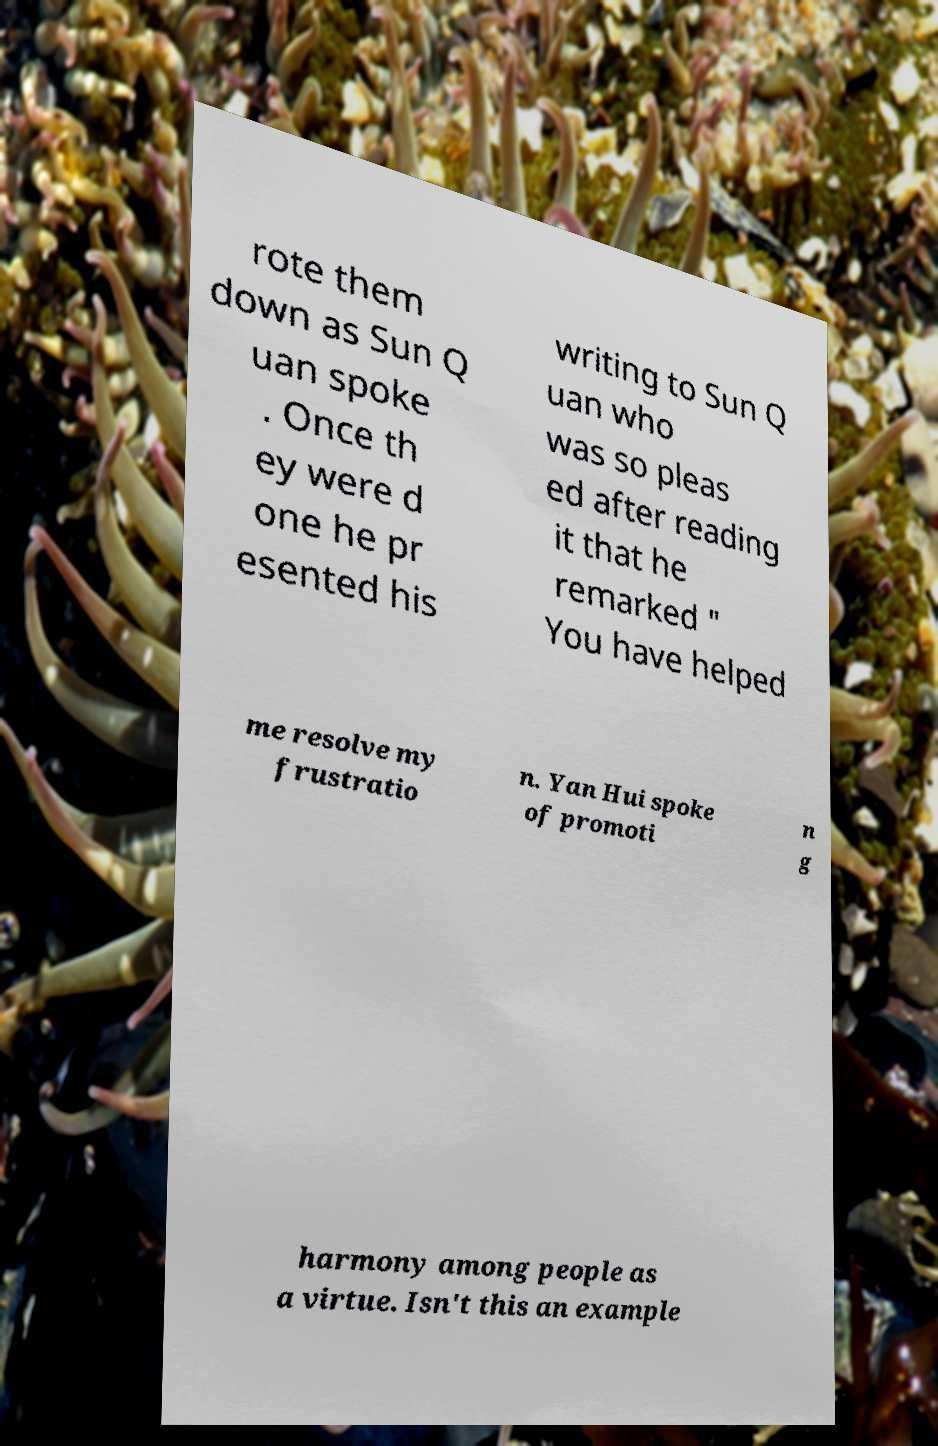I need the written content from this picture converted into text. Can you do that? rote them down as Sun Q uan spoke . Once th ey were d one he pr esented his writing to Sun Q uan who was so pleas ed after reading it that he remarked " You have helped me resolve my frustratio n. Yan Hui spoke of promoti n g harmony among people as a virtue. Isn't this an example 